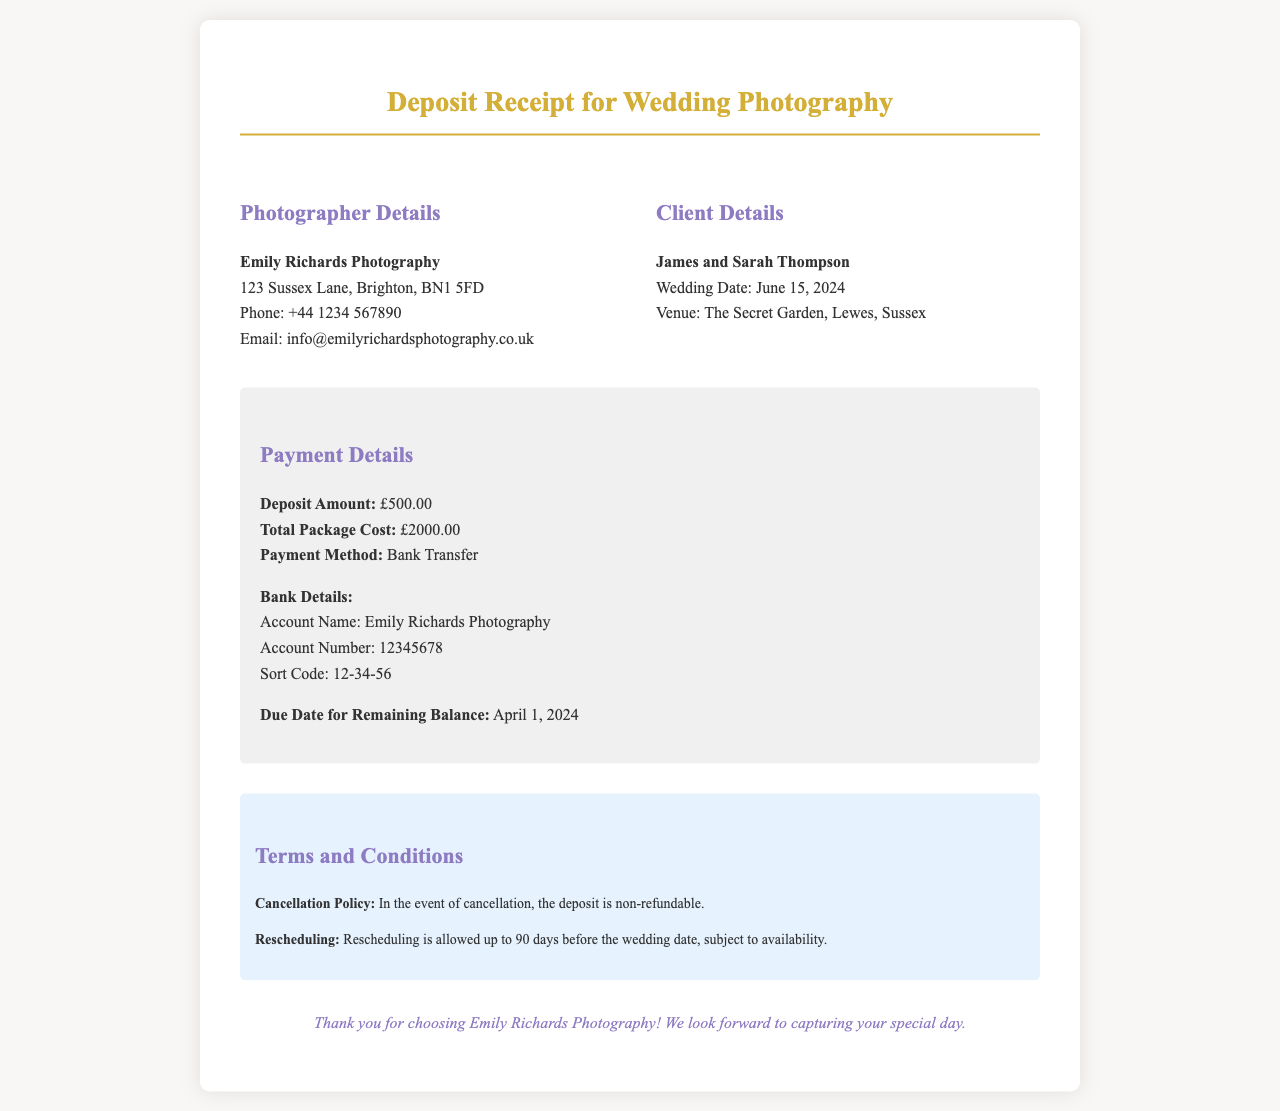What is the deposit amount? The deposit amount is clearly stated in the payment details section.
Answer: £500.00 Who is the wedding photographer? The name of the photographer is provided at the beginning of the document.
Answer: Emily Richards Photography What is the total package cost? The total package cost is specified in the payment details section.
Answer: £2000.00 When is the due date for the remaining balance? The due date for the remaining balance is mentioned in the payment details section.
Answer: April 1, 2024 What is the payment method? The payment method used for the deposit is outlined in the payment details section.
Answer: Bank Transfer What is the cancellation policy? The cancellation policy regarding the deposit is summarized in the terms and conditions section.
Answer: Non-refundable What is the couple’s wedding date? The wedding date is included in the client details part of the document.
Answer: June 15, 2024 What is the venue for the wedding? The venue for the wedding is listed in the client details section.
Answer: The Secret Garden, Lewes, Sussex How many days before the wedding can the clients reschedule? The allowed rescheduling period is mentioned in the terms and conditions section.
Answer: 90 days 